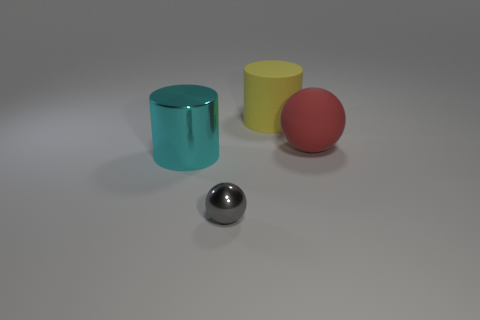Can you describe the composition of the figures in this image? Certainly! The image showcases four distinct objects placed against a light grey background. There's a cyan-colored glossy cylinder, a matte yellow cylinder, a matte red ball, and a reflective silver sphere. They are arranged with the cyan cylinder at the far left, followed by the yellow cylinder, the red ball, and the silver sphere in the foreground. 